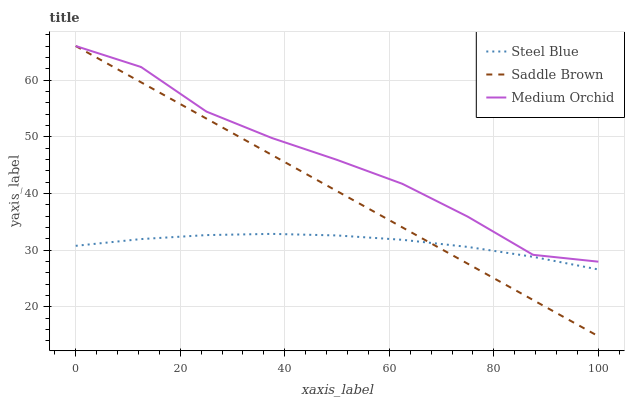Does Steel Blue have the minimum area under the curve?
Answer yes or no. Yes. Does Medium Orchid have the maximum area under the curve?
Answer yes or no. Yes. Does Saddle Brown have the minimum area under the curve?
Answer yes or no. No. Does Saddle Brown have the maximum area under the curve?
Answer yes or no. No. Is Saddle Brown the smoothest?
Answer yes or no. Yes. Is Medium Orchid the roughest?
Answer yes or no. Yes. Is Steel Blue the smoothest?
Answer yes or no. No. Is Steel Blue the roughest?
Answer yes or no. No. Does Saddle Brown have the lowest value?
Answer yes or no. Yes. Does Steel Blue have the lowest value?
Answer yes or no. No. Does Saddle Brown have the highest value?
Answer yes or no. Yes. Does Steel Blue have the highest value?
Answer yes or no. No. Is Steel Blue less than Medium Orchid?
Answer yes or no. Yes. Is Medium Orchid greater than Steel Blue?
Answer yes or no. Yes. Does Saddle Brown intersect Medium Orchid?
Answer yes or no. Yes. Is Saddle Brown less than Medium Orchid?
Answer yes or no. No. Is Saddle Brown greater than Medium Orchid?
Answer yes or no. No. Does Steel Blue intersect Medium Orchid?
Answer yes or no. No. 